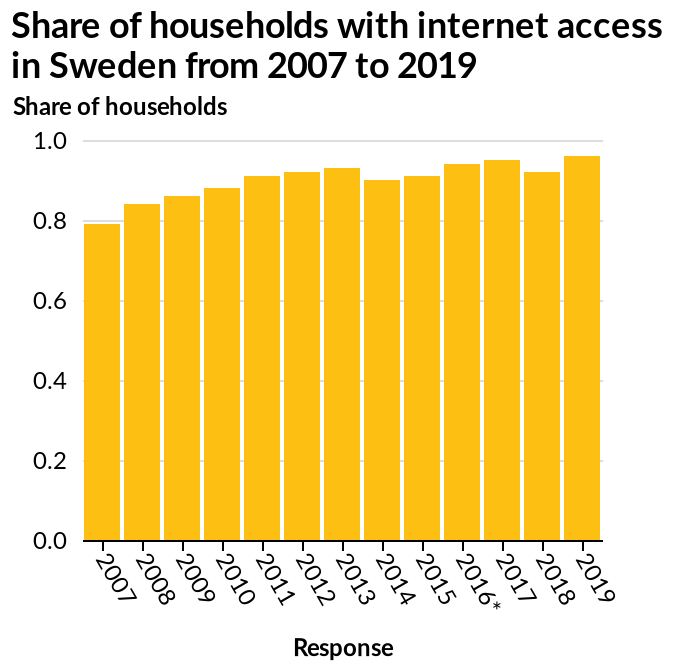<image>
What can be observed from the diagram regarding the share of households with Internet access?  The share of households with Internet access has increased between 2007 and 2019. Offer a thorough analysis of the image. For over a decade, since 2007, the number of Swedish households with internet has remained fairly stable, with a reliable and non-compressing average of 90% of households having internet. Describe the following image in detail Here a bar diagram is titled Share of households with internet access in Sweden from 2007 to 2019. A linear scale with a minimum of 0.0 and a maximum of 1.0 can be found along the y-axis, marked Share of households. There is a linear scale from 2007 to 2019 on the x-axis, labeled Response. What is the maximum value on the y-axis?  The maximum value on the y-axis is 1.0. What interesting trend can be observed in the number of households with Internet access between 2015 and 2017? There was a notable increase in the number of households with Internet access in the years 2015, 2016, and 2017. 